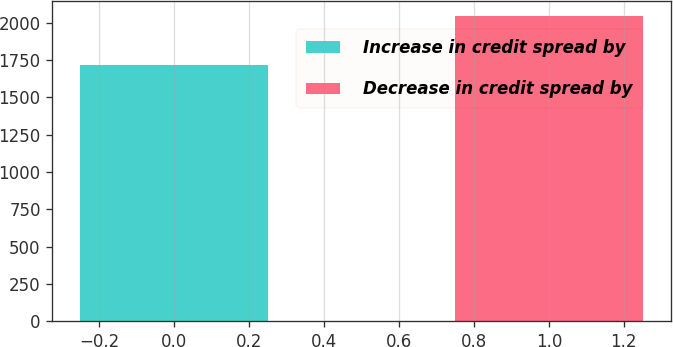<chart> <loc_0><loc_0><loc_500><loc_500><bar_chart><fcel>Increase in credit spread by<fcel>Decrease in credit spread by<nl><fcel>1714<fcel>2047<nl></chart> 